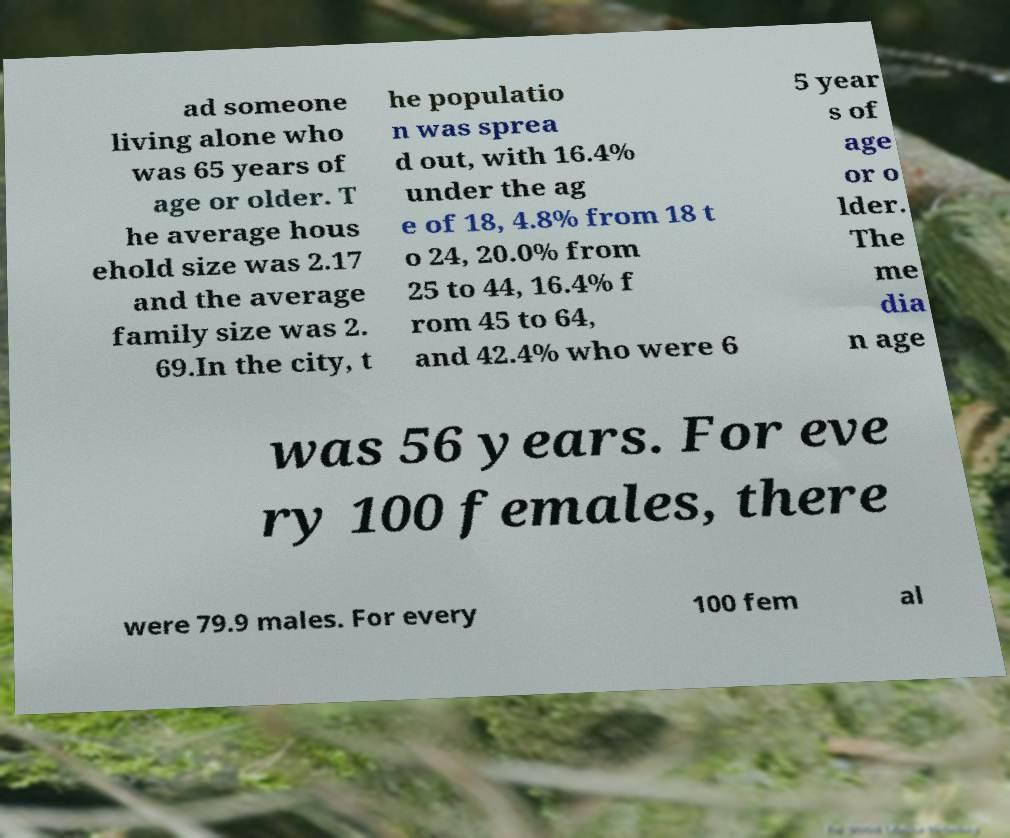Could you assist in decoding the text presented in this image and type it out clearly? ad someone living alone who was 65 years of age or older. T he average hous ehold size was 2.17 and the average family size was 2. 69.In the city, t he populatio n was sprea d out, with 16.4% under the ag e of 18, 4.8% from 18 t o 24, 20.0% from 25 to 44, 16.4% f rom 45 to 64, and 42.4% who were 6 5 year s of age or o lder. The me dia n age was 56 years. For eve ry 100 females, there were 79.9 males. For every 100 fem al 